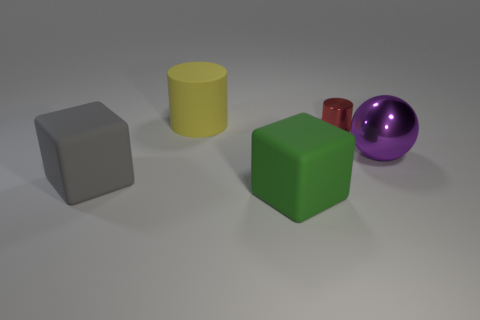Which object appears to be the smallest and what is its color? The smallest object in the image is the cylinder, and its color is red. 